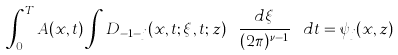Convert formula to latex. <formula><loc_0><loc_0><loc_500><loc_500>\int _ { 0 } ^ { T } A ( x , t ) \int D _ { - 1 - j } ( x , t ; \xi , t ; z ) \ { \frac { d \xi } { { ( 2 \pi ) ^ { \nu - 1 } } } } \ d t = \psi _ { j } ( x , z )</formula> 